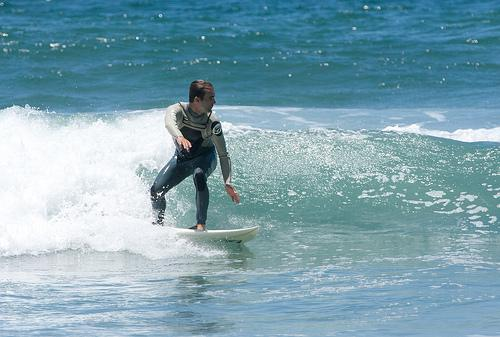Question: what is the man standing on?
Choices:
A. Waterskis.
B. A surfboard.
C. A snowboard.
D. A wooden plank.
Answer with the letter. Answer: B Question: what is the man doing?
Choices:
A. Snowboarding.
B. Waterskiing.
C. Surfing.
D. Parasailing.
Answer with the letter. Answer: C Question: what is the surfboard riding?
Choices:
A. A car roof.
B. A boat.
C. The beach.
D. A wave.
Answer with the letter. Answer: D 